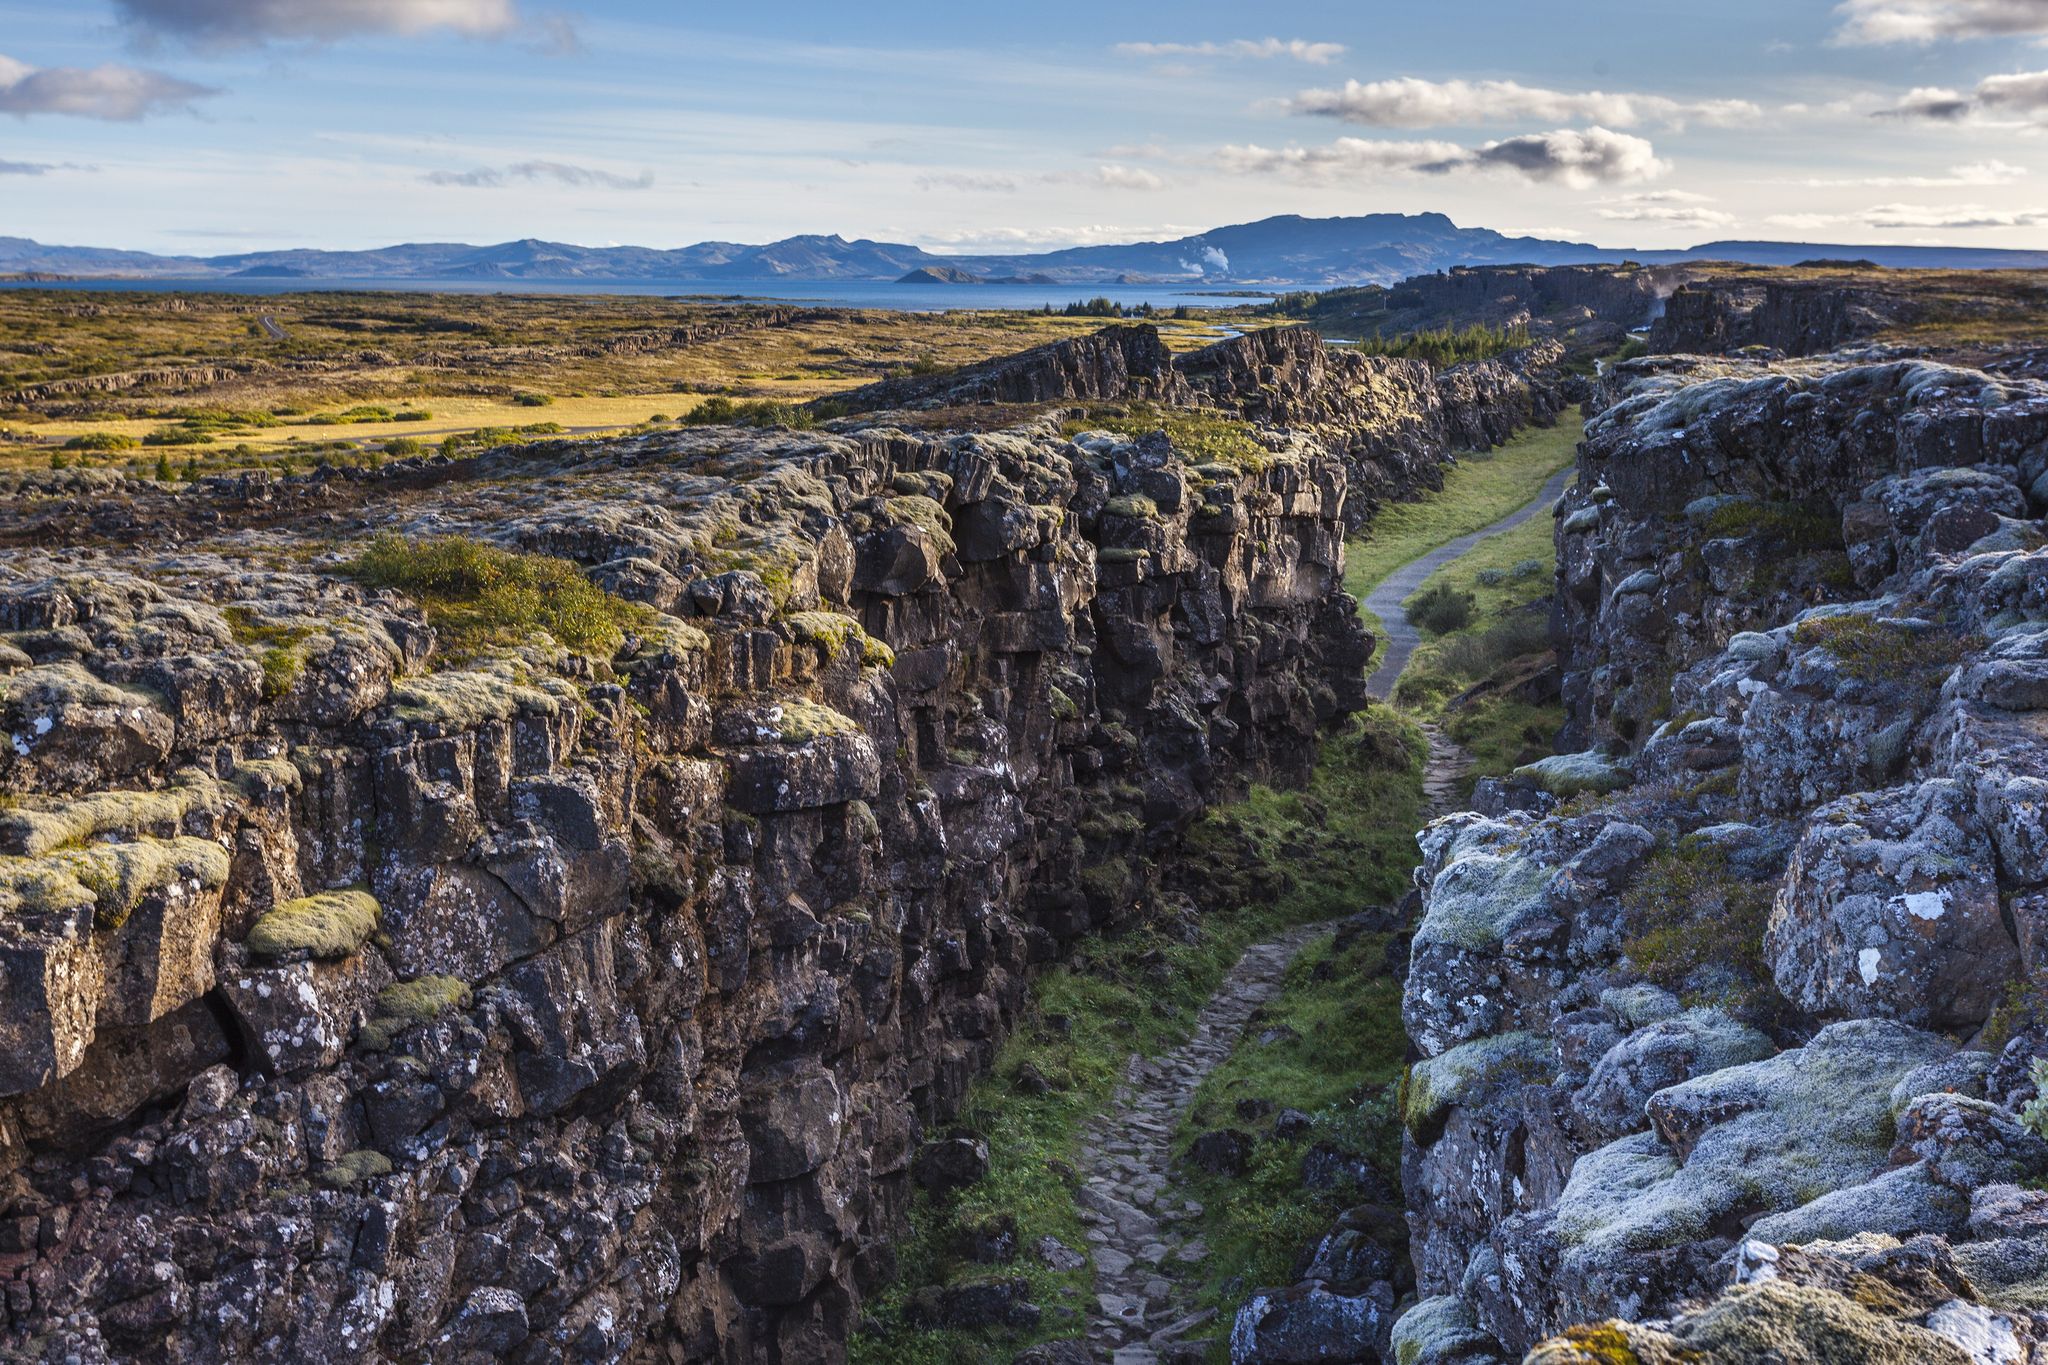What is this photo about? This photograph captures the stunning landscape of Þingvellir National Park in Iceland. The viewer's attention is immediately drawn to a deep and impressive rift that slices through the earth, reflecting the park's unique geological heritage. A winding path meanders through the gorge, inviting one to explore its natural beauty up close. Flanking the rift are towering cliffs adorned with patches of green moss and lichen, contrasting beautifully with the rocky terrain. The rugged textures and earthy colors provide a sense of depth and scale to the scene. Beyond the gorge, the landscape stretches into a vast plain, culminating in a tranquil lake that mirrors the sky above. Distant mountains form the backdrop, adding to the dramatic allure of this location. The image showcases the harmonious blend of geological formations and the serene Icelandic wilderness, making Þingvellir a must-visit for nature enthusiasts. 